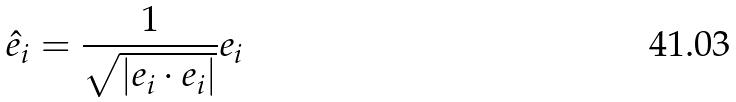Convert formula to latex. <formula><loc_0><loc_0><loc_500><loc_500>\hat { e } _ { i } = \frac { 1 } { \sqrt { | e _ { i } \cdot e _ { i } | } } e _ { i }</formula> 